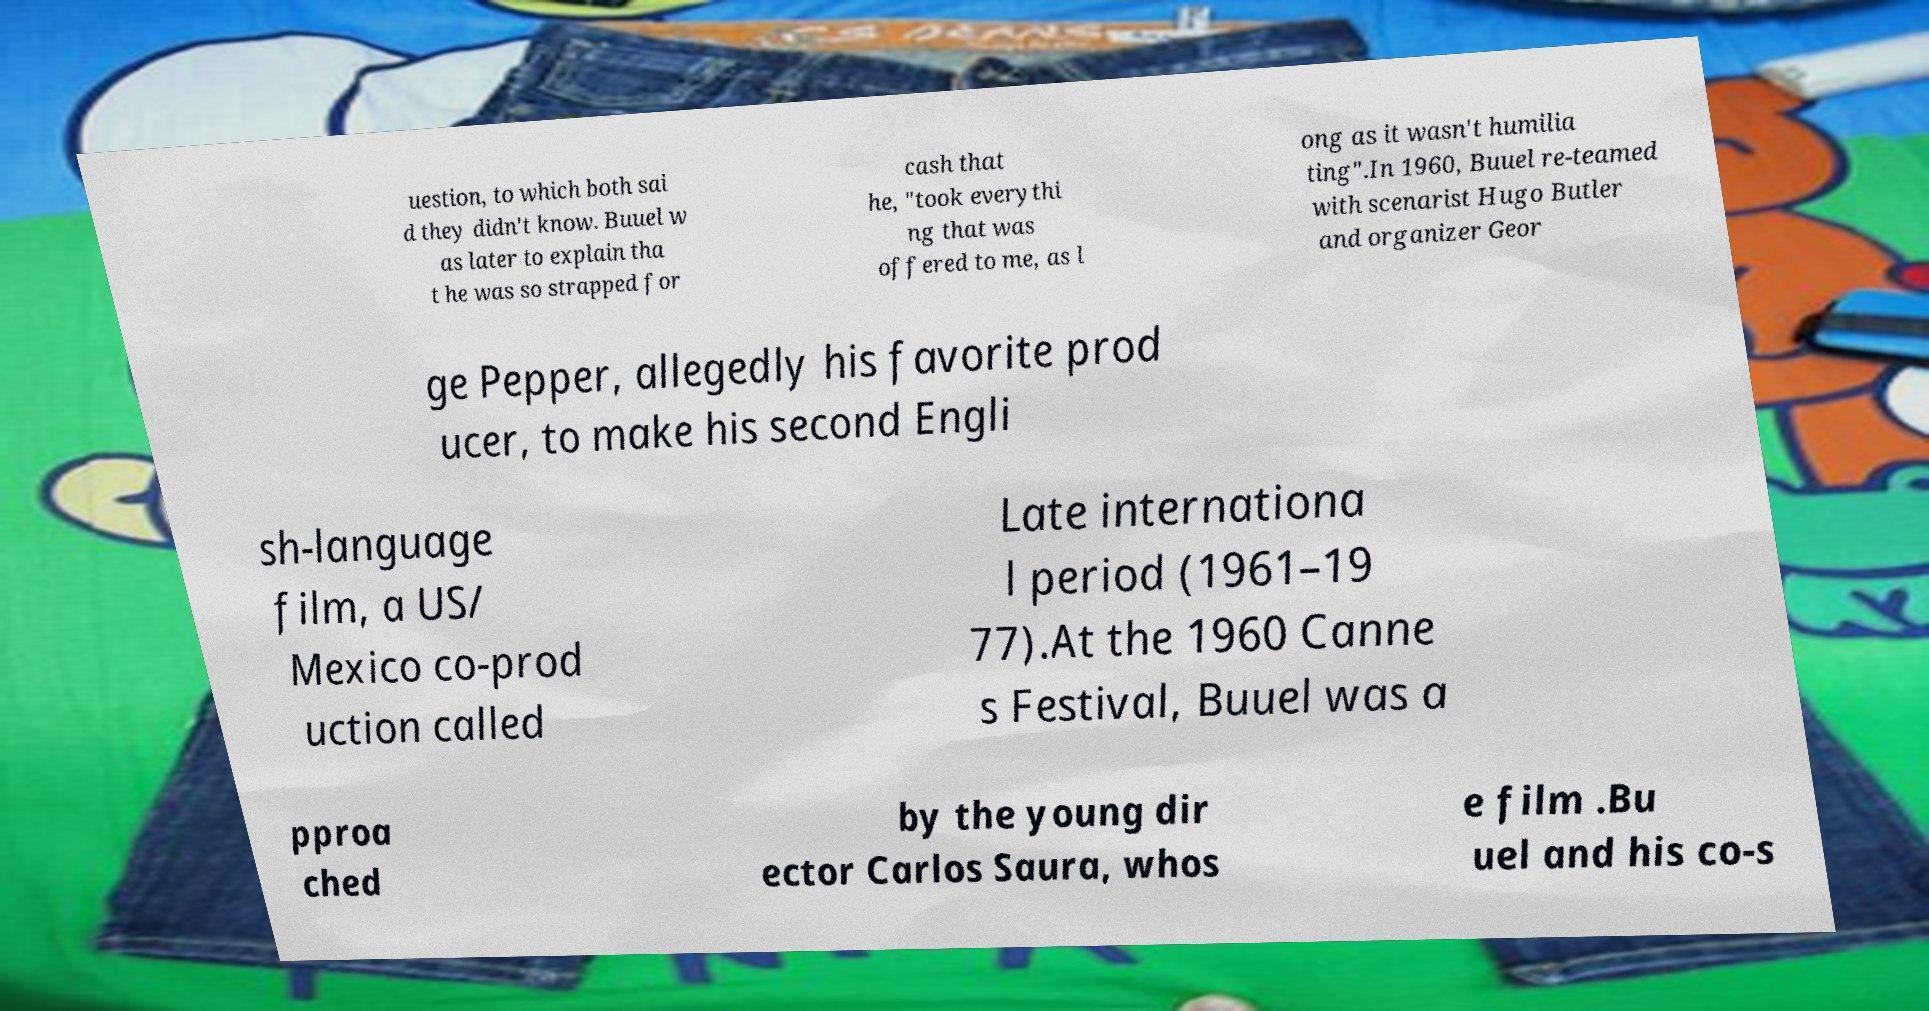Could you extract and type out the text from this image? uestion, to which both sai d they didn't know. Buuel w as later to explain tha t he was so strapped for cash that he, "took everythi ng that was offered to me, as l ong as it wasn't humilia ting".In 1960, Buuel re-teamed with scenarist Hugo Butler and organizer Geor ge Pepper, allegedly his favorite prod ucer, to make his second Engli sh-language film, a US/ Mexico co-prod uction called Late internationa l period (1961–19 77).At the 1960 Canne s Festival, Buuel was a pproa ched by the young dir ector Carlos Saura, whos e film .Bu uel and his co-s 